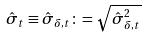Convert formula to latex. <formula><loc_0><loc_0><loc_500><loc_500>\hat { \sigma } _ { t } \equiv \hat { \sigma } _ { \delta , t } \colon = \sqrt { \hat { \sigma } ^ { 2 } _ { \delta , t } }</formula> 